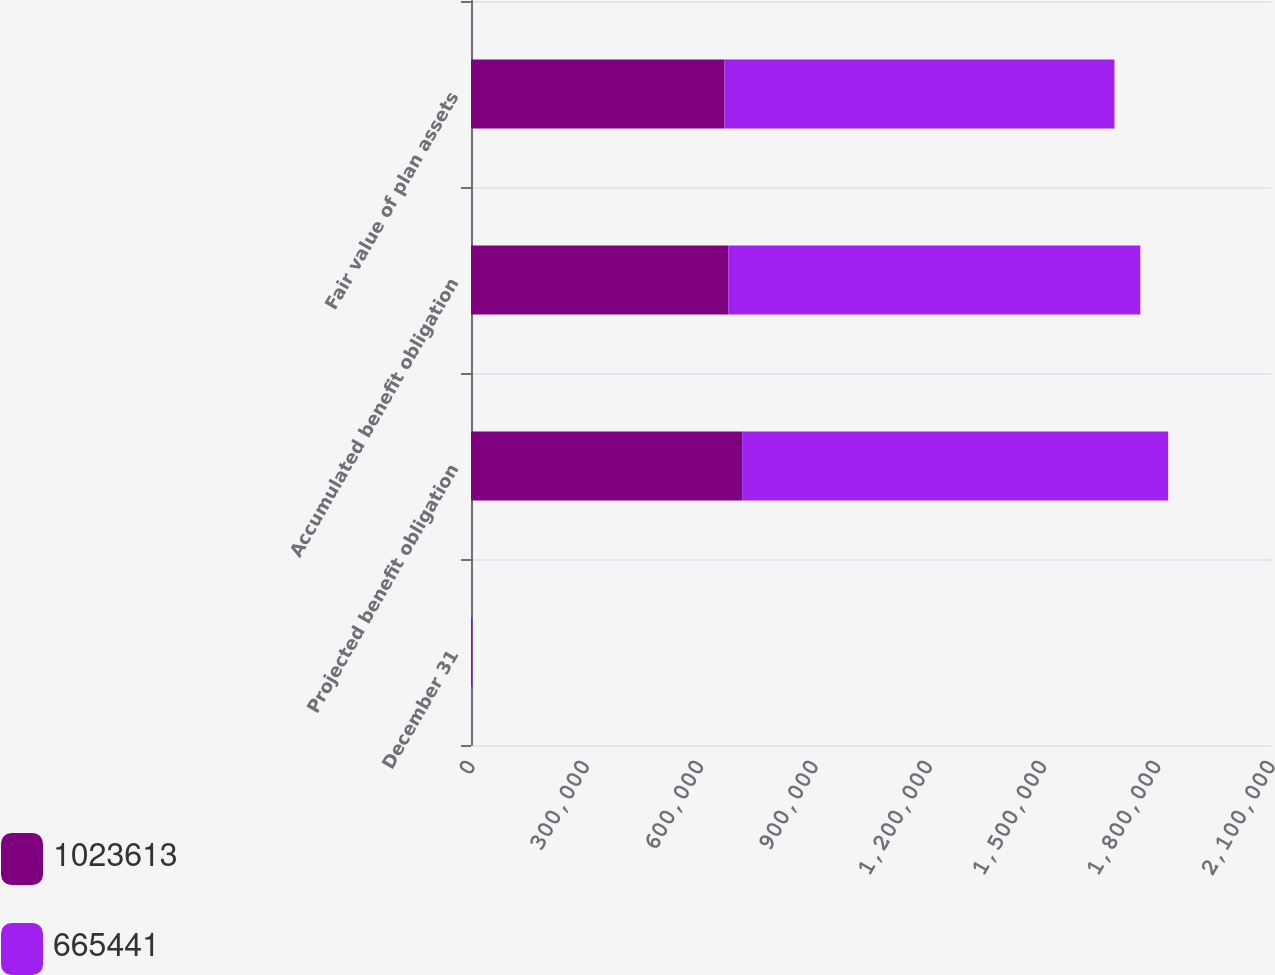Convert chart. <chart><loc_0><loc_0><loc_500><loc_500><stacked_bar_chart><ecel><fcel>December 31<fcel>Projected benefit obligation<fcel>Accumulated benefit obligation<fcel>Fair value of plan assets<nl><fcel>1.02361e+06<fcel>2017<fcel>711767<fcel>675660<fcel>665441<nl><fcel>665441<fcel>2016<fcel>1.11829e+06<fcel>1.08125e+06<fcel>1.02361e+06<nl></chart> 